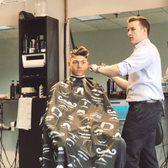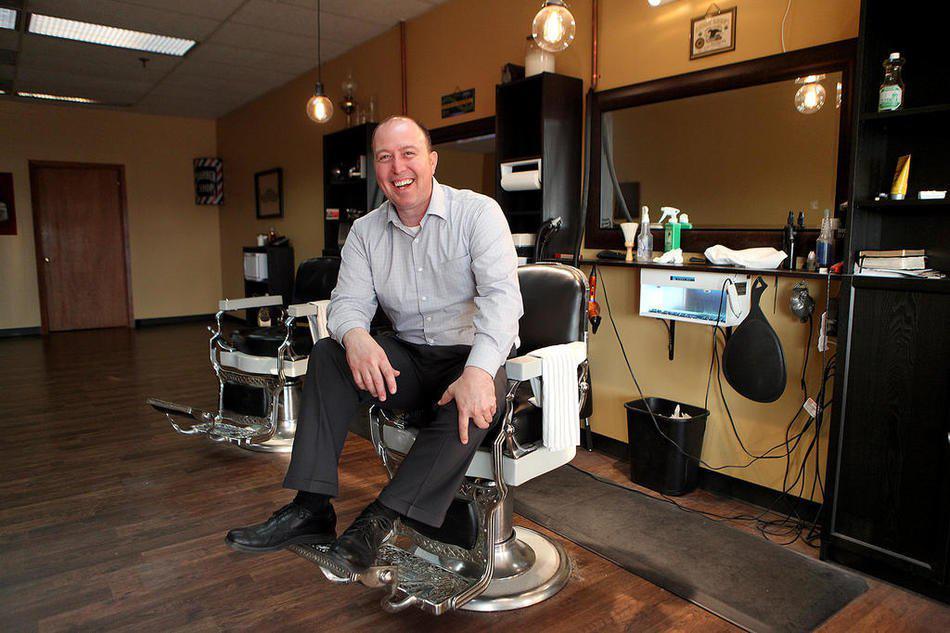The first image is the image on the left, the second image is the image on the right. Given the left and right images, does the statement "An image shows a male barber with eyeglasses behind a customer, working on hair." hold true? Answer yes or no. No. The first image is the image on the left, the second image is the image on the right. Analyze the images presented: Is the assertion "The male barber in the image on the right is wearing glasses." valid? Answer yes or no. No. 